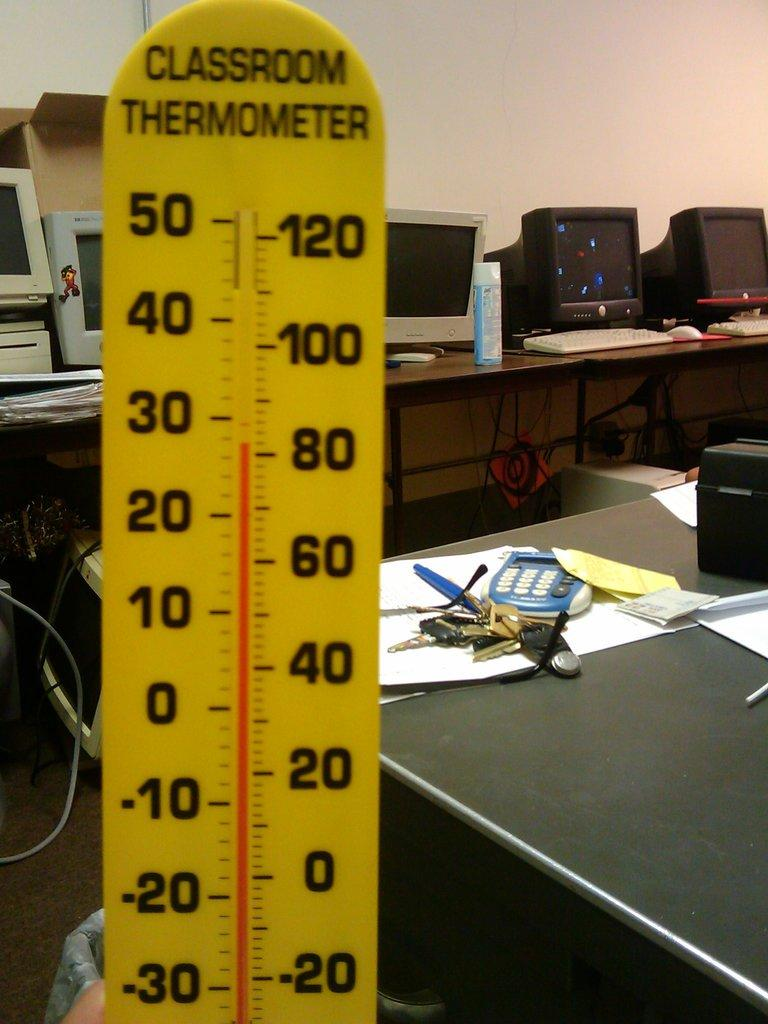<image>
Write a terse but informative summary of the picture. A yello therometer that is reading 80 degrees. 